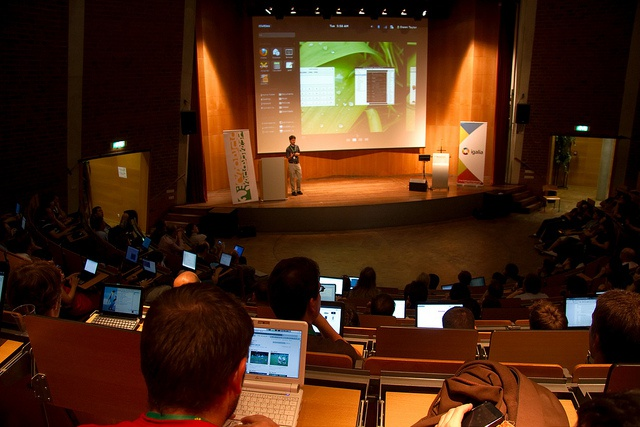Describe the objects in this image and their specific colors. I can see tv in black, maroon, tan, and ivory tones, people in black, maroon, and darkgreen tones, people in black, maroon, and brown tones, laptop in black, tan, brown, and lightblue tones, and people in black, maroon, and white tones in this image. 